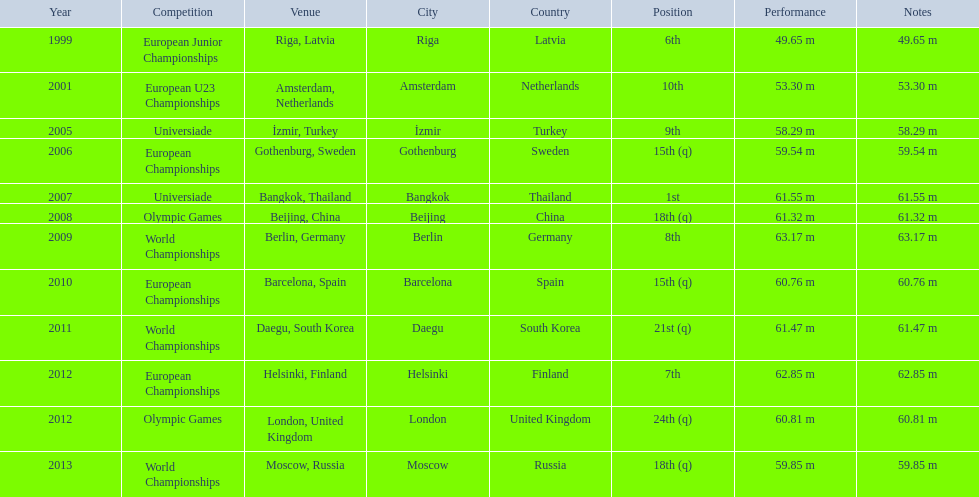What are the years that gerhard mayer participated? 1999, 2001, 2005, 2006, 2007, 2008, 2009, 2010, 2011, 2012, 2012, 2013. Which years were earlier than 2007? 1999, 2001, 2005, 2006. What was the best placing for these years? 6th. 